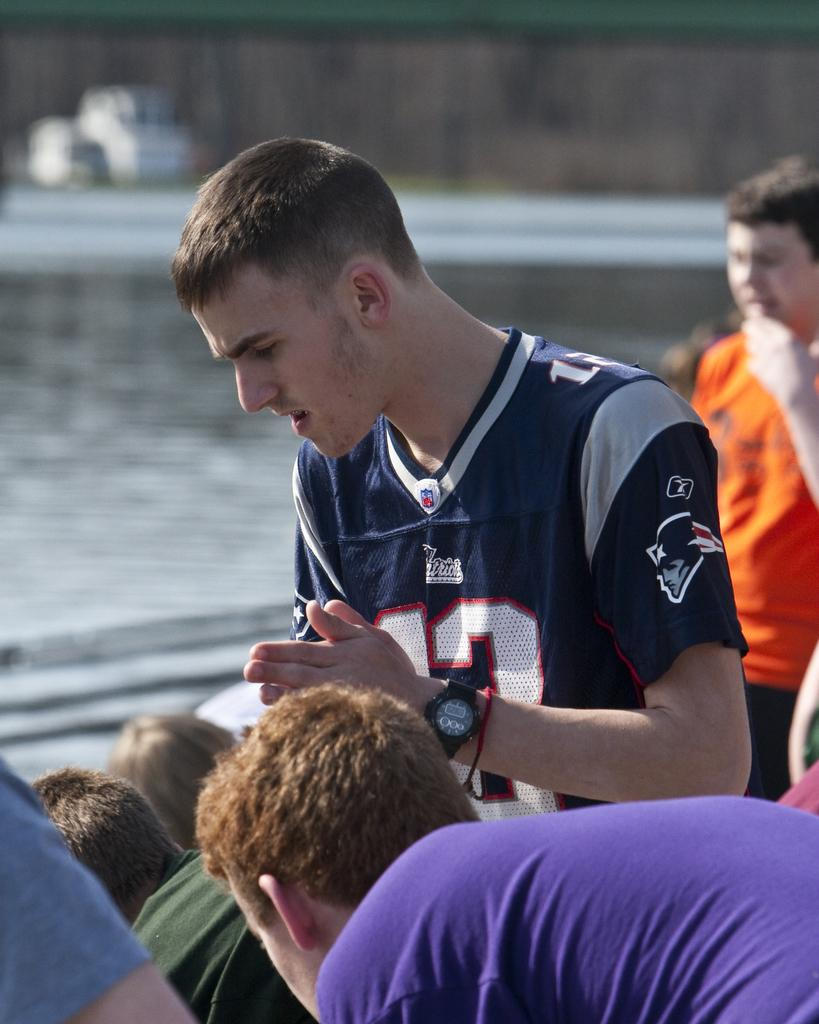Provide a one-sentence caption for the provided image. people on a boat with one man wearing a number 12 patriots jersey. 